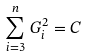Convert formula to latex. <formula><loc_0><loc_0><loc_500><loc_500>\sum _ { i = 3 } ^ { n } \, G _ { i } ^ { 2 } = C</formula> 